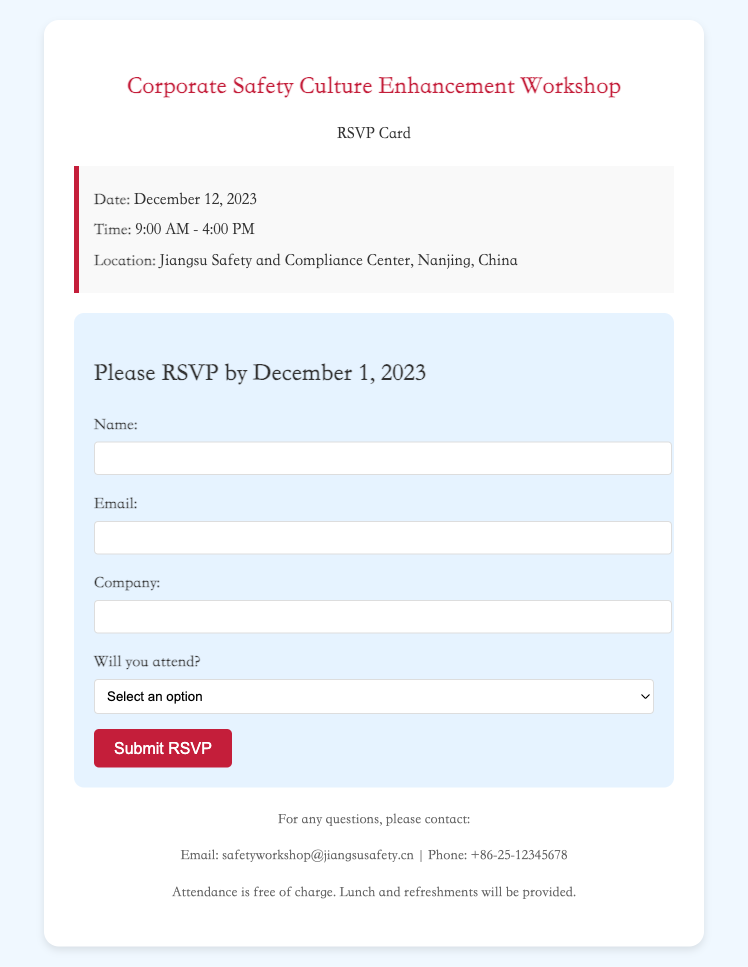what is the date of the workshop? The date of the workshop is explicitly stated in the document as December 12, 2023.
Answer: December 12, 2023 what time does the workshop start? The starting time is mentioned in the document as 9:00 AM.
Answer: 9:00 AM where is the workshop located? The location is provided in the document as Jiangsu Safety and Compliance Center, Nanjing, China.
Answer: Jiangsu Safety and Compliance Center, Nanjing, China when is the RSVP deadline? The RSVP deadline is given in the document as December 1, 2023.
Answer: December 1, 2023 is there a cost to attend the workshop? The document states that attendance is free of charge.
Answer: free what will be provided during the workshop? The document mentions that lunch and refreshments will be provided.
Answer: lunch and refreshments how should participants respond to the RSVP? Participants should fill out the RSVP form provided in the document.
Answer: RSVP form what is the email for questions regarding the workshop? The document lists the email address for questions as safetyworkshop@jiangsusafety.cn.
Answer: safetyworkshop@jiangsusafety.cn what is the phone number for queries related to the workshop? The document provides a contact phone number as +86-25-12345678.
Answer: +86-25-12345678 